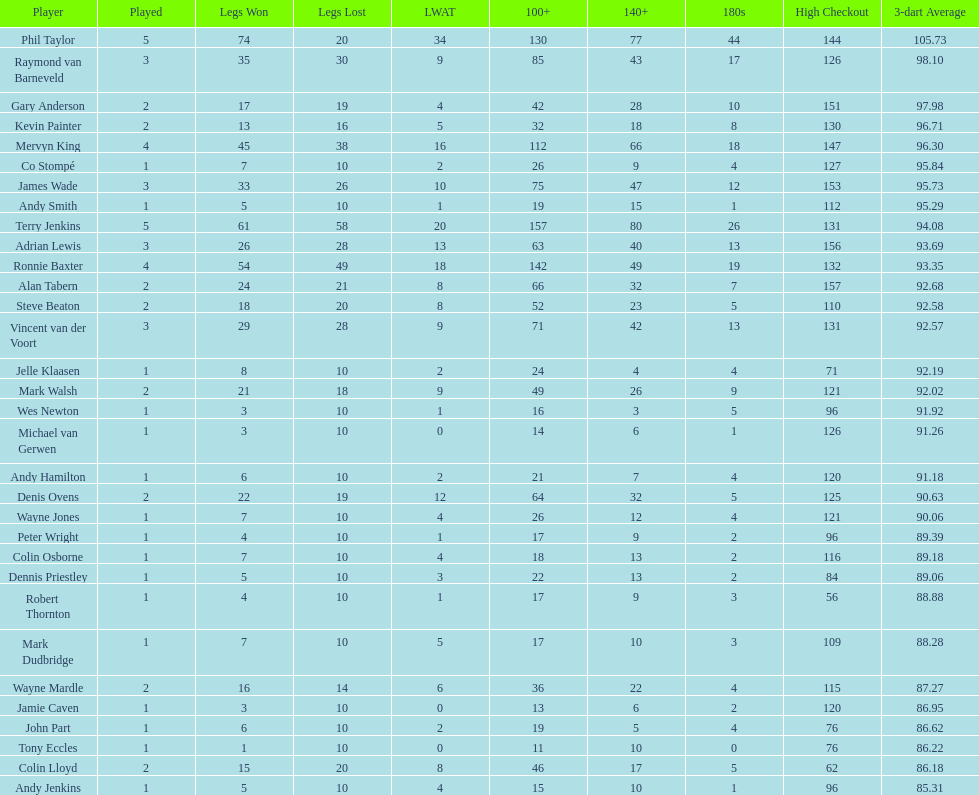Who won the highest number of legs in the 2009 world matchplay? Phil Taylor. 